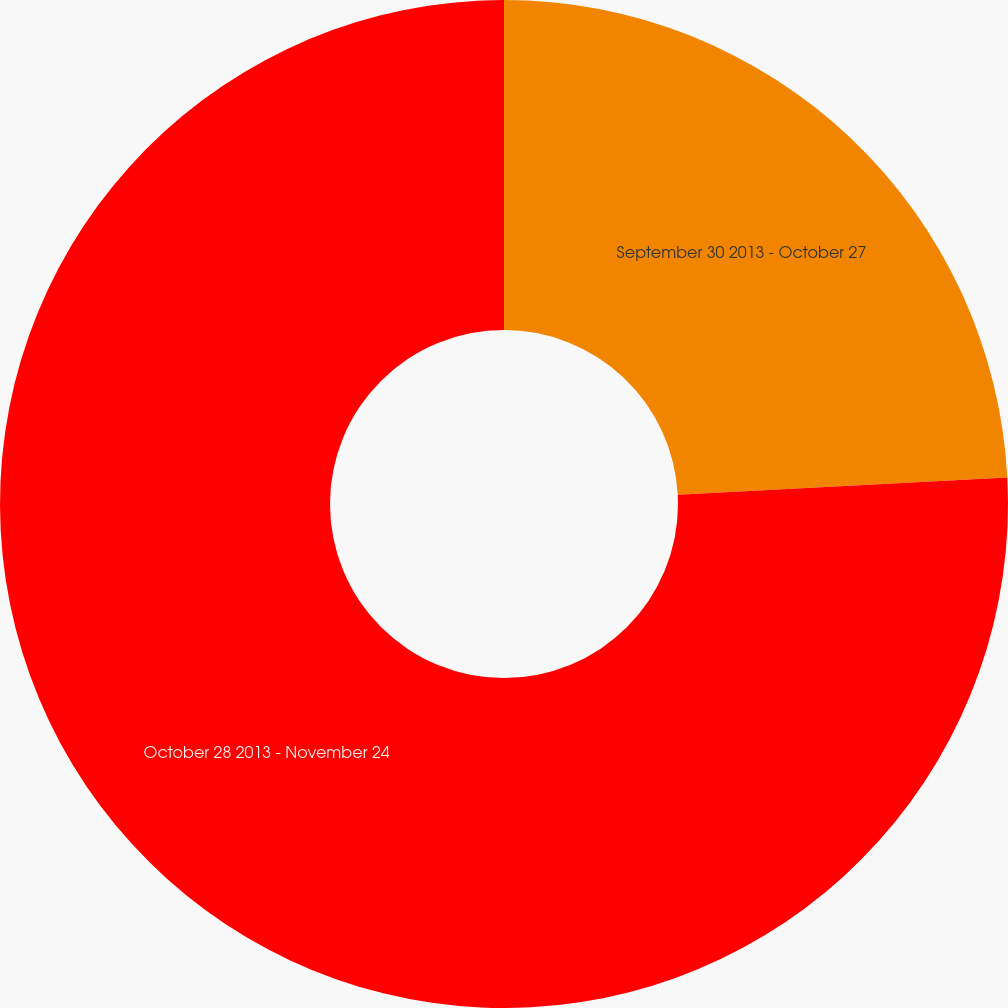Convert chart to OTSL. <chart><loc_0><loc_0><loc_500><loc_500><pie_chart><fcel>September 30 2013 - October 27<fcel>October 28 2013 - November 24<nl><fcel>24.16%<fcel>75.84%<nl></chart> 